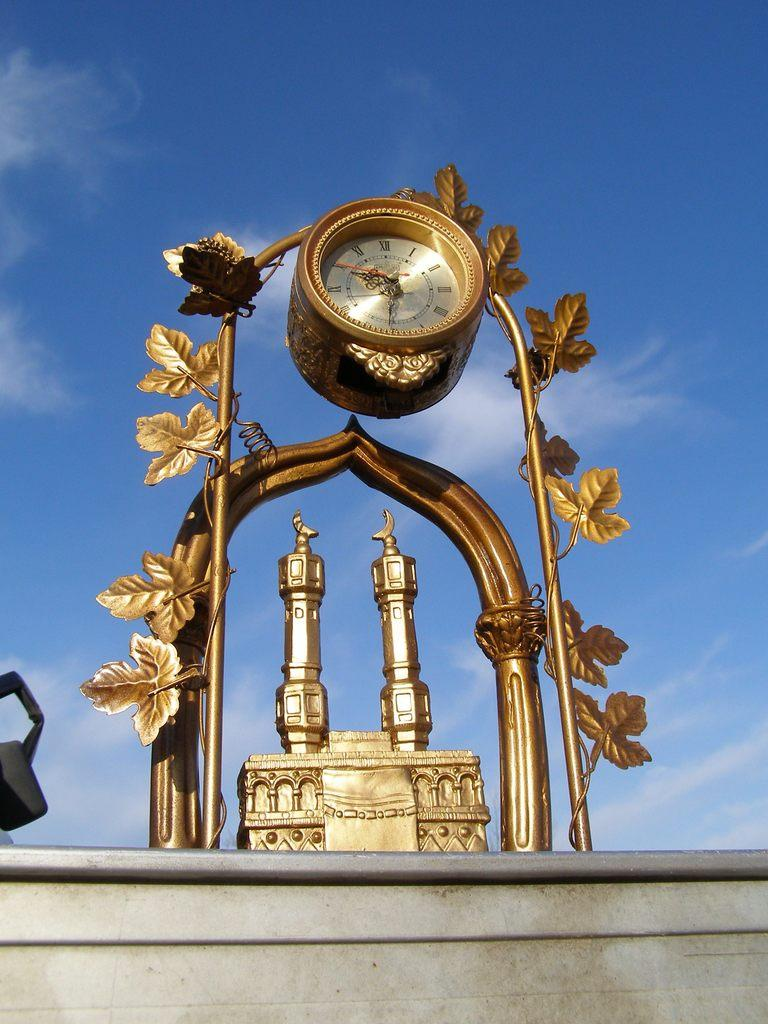<image>
Relay a brief, clear account of the picture shown. A large gold clock has the time of 9:31. 